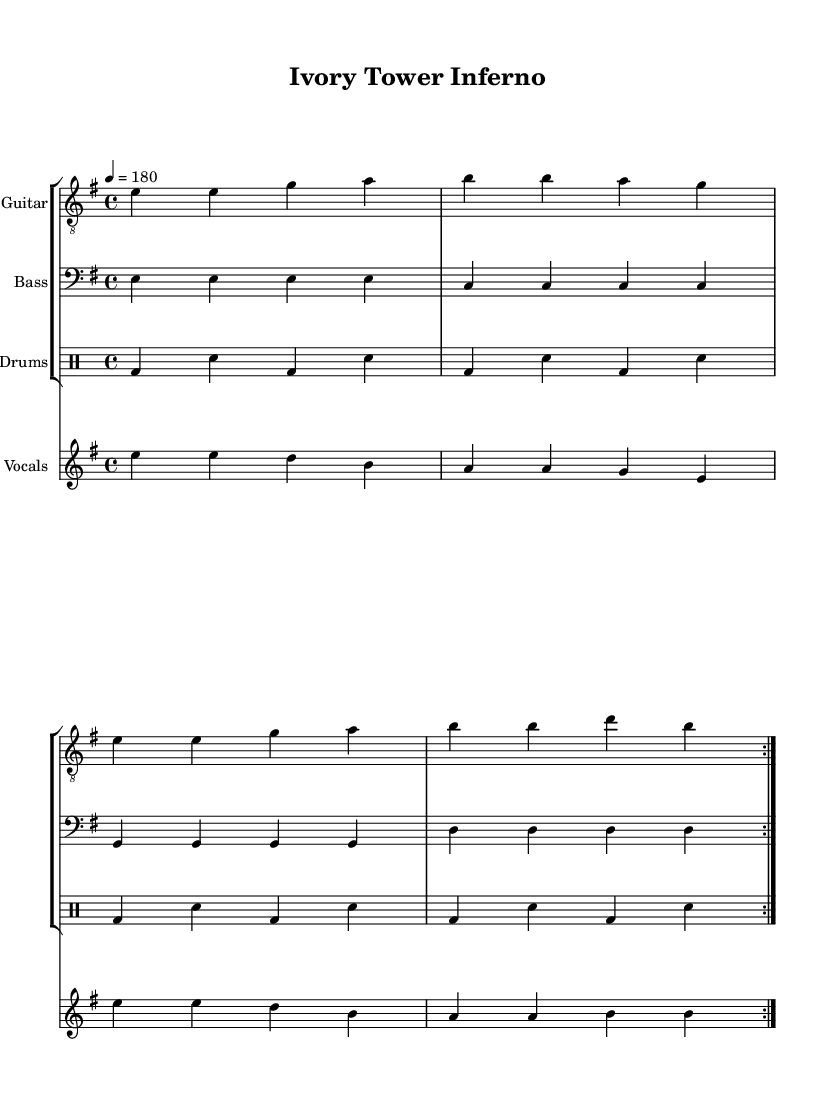What is the key signature of this music? The key signature is indicated by the presence of one sharp, which is F#. Therefore, it is E minor.
Answer: E minor What is the time signature of this music? The time signature appears at the beginning and is indicated as 4/4, meaning there are four beats per measure.
Answer: 4/4 What is the tempo marking used in this composition? The tempo marking is indicated at the beginning with the note value and speed, which is 180 beats per minute.
Answer: 180 How many measures are repeated in the song? The song includes a repeat section indicated by "volta" and repeats the previous measures two times, totaling eight measures in this repeated section.
Answer: 2 What instrument is playing the melody? The melody is primarily played on the guitar as it is the part transcribed for the treble staff in this score.
Answer: Guitar What lyrical theme is presented in the song? The lyrics critique academic institutions, symbolizing the struggle against pretension and the breaking of academic chains.
Answer: Anarcho-punk critique What type of drum pattern is utilized in this piece? The drum notation shows a consistent pattern of bass and snare hits, typical of punk, which creates a driving rhythm throughout the piece.
Answer: Punk rhythm 